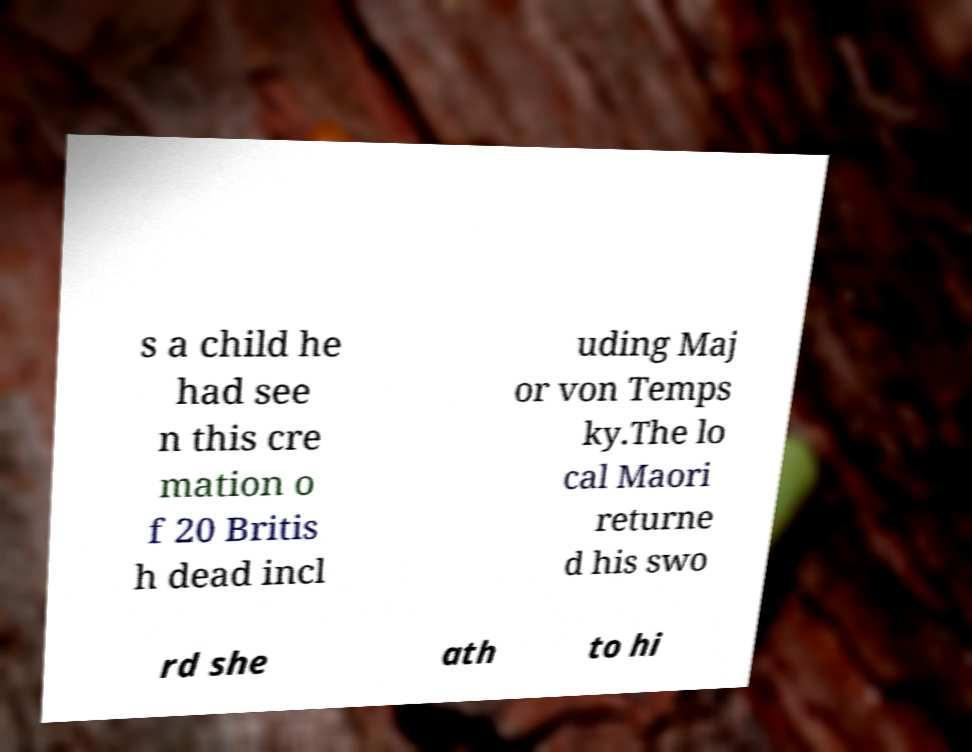Could you assist in decoding the text presented in this image and type it out clearly? s a child he had see n this cre mation o f 20 Britis h dead incl uding Maj or von Temps ky.The lo cal Maori returne d his swo rd she ath to hi 